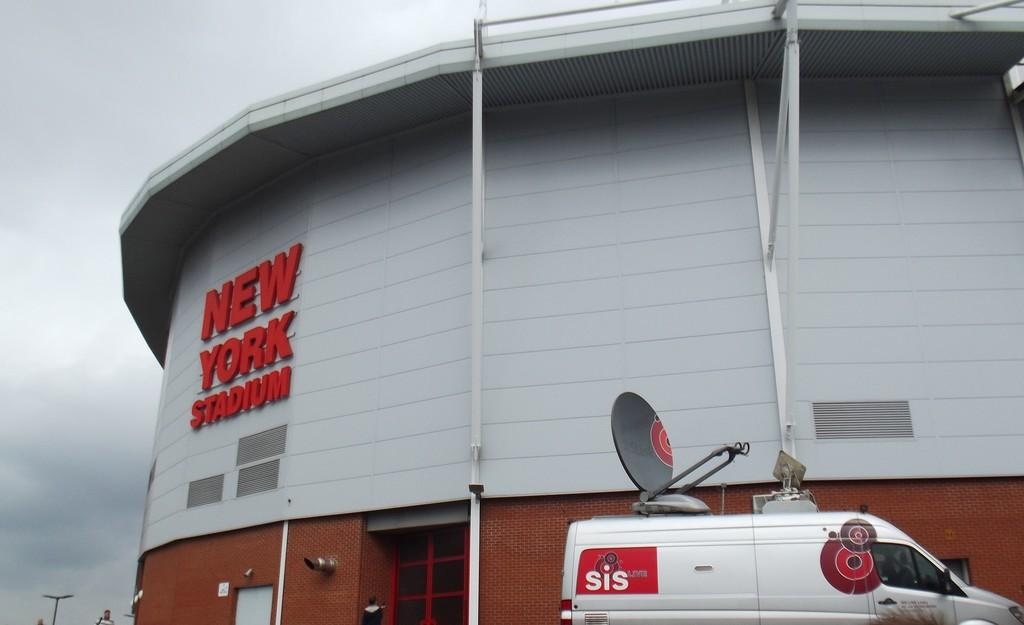Provide a one-sentence caption for the provided image. White van parked in front of New York Stadium. 